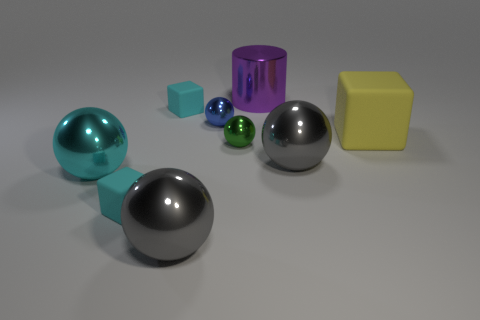There is a block that is the same size as the purple metal cylinder; what is it made of?
Your answer should be very brief. Rubber. How many other things are there of the same size as the purple cylinder?
Your answer should be compact. 4. What number of cylinders are either purple shiny things or tiny cyan rubber things?
Your answer should be compact. 1. There is a gray object that is behind the big sphere left of the tiny thing in front of the big cyan object; what is its material?
Your answer should be very brief. Metal. What number of yellow things are made of the same material as the cyan ball?
Give a very brief answer. 0. Do the gray metallic thing behind the cyan shiny sphere and the purple object have the same size?
Provide a succinct answer. Yes. There is a big cylinder that is made of the same material as the big cyan sphere; what is its color?
Keep it short and to the point. Purple. There is a large purple cylinder; what number of large gray objects are left of it?
Provide a short and direct response. 1. Is the color of the metal object right of the purple cylinder the same as the large metallic thing that is in front of the big cyan metal ball?
Make the answer very short. Yes. What color is the other tiny metal thing that is the same shape as the green metallic thing?
Offer a terse response. Blue. 